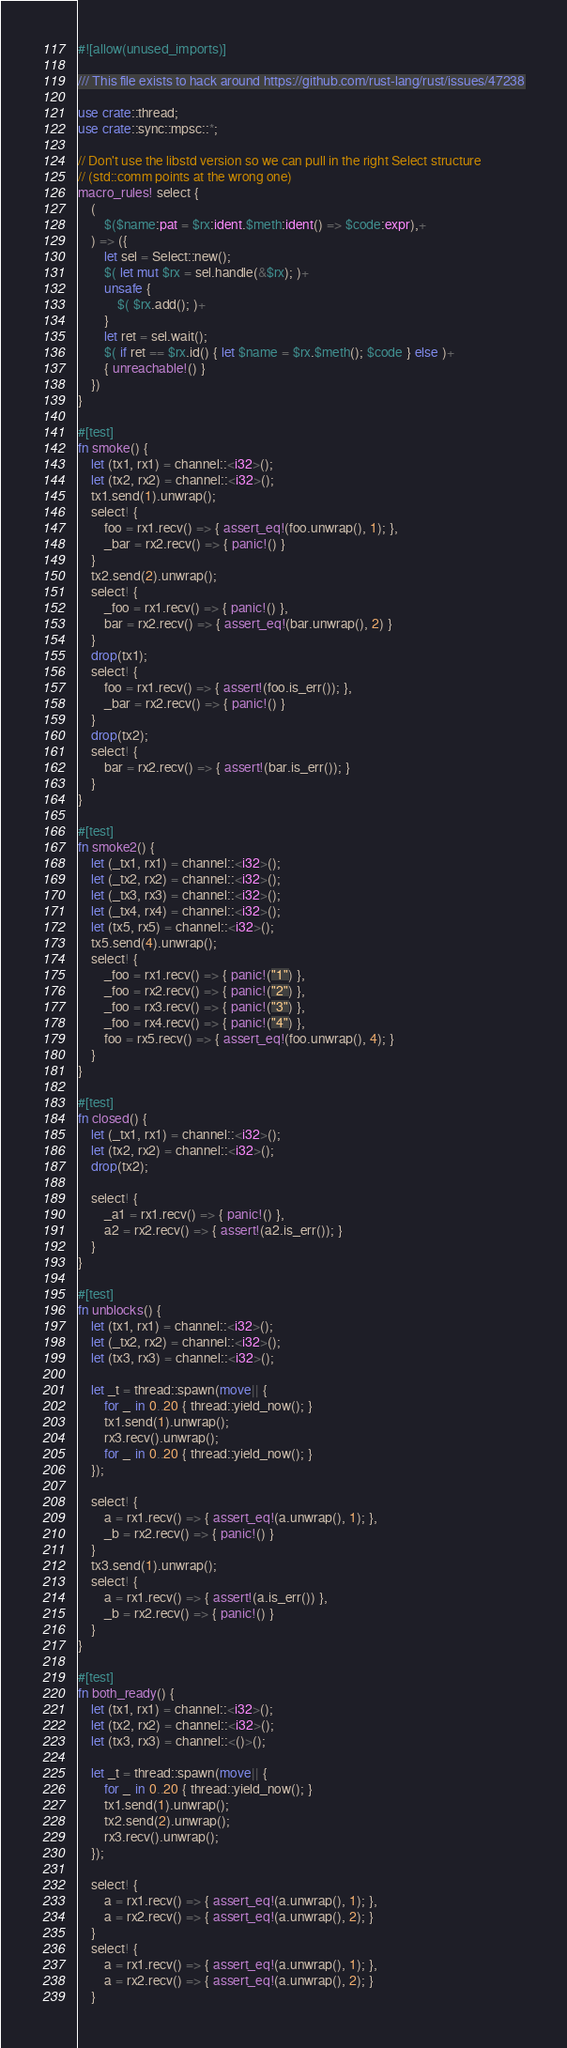<code> <loc_0><loc_0><loc_500><loc_500><_Rust_>#![allow(unused_imports)]

/// This file exists to hack around https://github.com/rust-lang/rust/issues/47238

use crate::thread;
use crate::sync::mpsc::*;

// Don't use the libstd version so we can pull in the right Select structure
// (std::comm points at the wrong one)
macro_rules! select {
    (
        $($name:pat = $rx:ident.$meth:ident() => $code:expr),+
    ) => ({
        let sel = Select::new();
        $( let mut $rx = sel.handle(&$rx); )+
        unsafe {
            $( $rx.add(); )+
        }
        let ret = sel.wait();
        $( if ret == $rx.id() { let $name = $rx.$meth(); $code } else )+
        { unreachable!() }
    })
}

#[test]
fn smoke() {
    let (tx1, rx1) = channel::<i32>();
    let (tx2, rx2) = channel::<i32>();
    tx1.send(1).unwrap();
    select! {
        foo = rx1.recv() => { assert_eq!(foo.unwrap(), 1); },
        _bar = rx2.recv() => { panic!() }
    }
    tx2.send(2).unwrap();
    select! {
        _foo = rx1.recv() => { panic!() },
        bar = rx2.recv() => { assert_eq!(bar.unwrap(), 2) }
    }
    drop(tx1);
    select! {
        foo = rx1.recv() => { assert!(foo.is_err()); },
        _bar = rx2.recv() => { panic!() }
    }
    drop(tx2);
    select! {
        bar = rx2.recv() => { assert!(bar.is_err()); }
    }
}

#[test]
fn smoke2() {
    let (_tx1, rx1) = channel::<i32>();
    let (_tx2, rx2) = channel::<i32>();
    let (_tx3, rx3) = channel::<i32>();
    let (_tx4, rx4) = channel::<i32>();
    let (tx5, rx5) = channel::<i32>();
    tx5.send(4).unwrap();
    select! {
        _foo = rx1.recv() => { panic!("1") },
        _foo = rx2.recv() => { panic!("2") },
        _foo = rx3.recv() => { panic!("3") },
        _foo = rx4.recv() => { panic!("4") },
        foo = rx5.recv() => { assert_eq!(foo.unwrap(), 4); }
    }
}

#[test]
fn closed() {
    let (_tx1, rx1) = channel::<i32>();
    let (tx2, rx2) = channel::<i32>();
    drop(tx2);

    select! {
        _a1 = rx1.recv() => { panic!() },
        a2 = rx2.recv() => { assert!(a2.is_err()); }
    }
}

#[test]
fn unblocks() {
    let (tx1, rx1) = channel::<i32>();
    let (_tx2, rx2) = channel::<i32>();
    let (tx3, rx3) = channel::<i32>();

    let _t = thread::spawn(move|| {
        for _ in 0..20 { thread::yield_now(); }
        tx1.send(1).unwrap();
        rx3.recv().unwrap();
        for _ in 0..20 { thread::yield_now(); }
    });

    select! {
        a = rx1.recv() => { assert_eq!(a.unwrap(), 1); },
        _b = rx2.recv() => { panic!() }
    }
    tx3.send(1).unwrap();
    select! {
        a = rx1.recv() => { assert!(a.is_err()) },
        _b = rx2.recv() => { panic!() }
    }
}

#[test]
fn both_ready() {
    let (tx1, rx1) = channel::<i32>();
    let (tx2, rx2) = channel::<i32>();
    let (tx3, rx3) = channel::<()>();

    let _t = thread::spawn(move|| {
        for _ in 0..20 { thread::yield_now(); }
        tx1.send(1).unwrap();
        tx2.send(2).unwrap();
        rx3.recv().unwrap();
    });

    select! {
        a = rx1.recv() => { assert_eq!(a.unwrap(), 1); },
        a = rx2.recv() => { assert_eq!(a.unwrap(), 2); }
    }
    select! {
        a = rx1.recv() => { assert_eq!(a.unwrap(), 1); },
        a = rx2.recv() => { assert_eq!(a.unwrap(), 2); }
    }</code> 